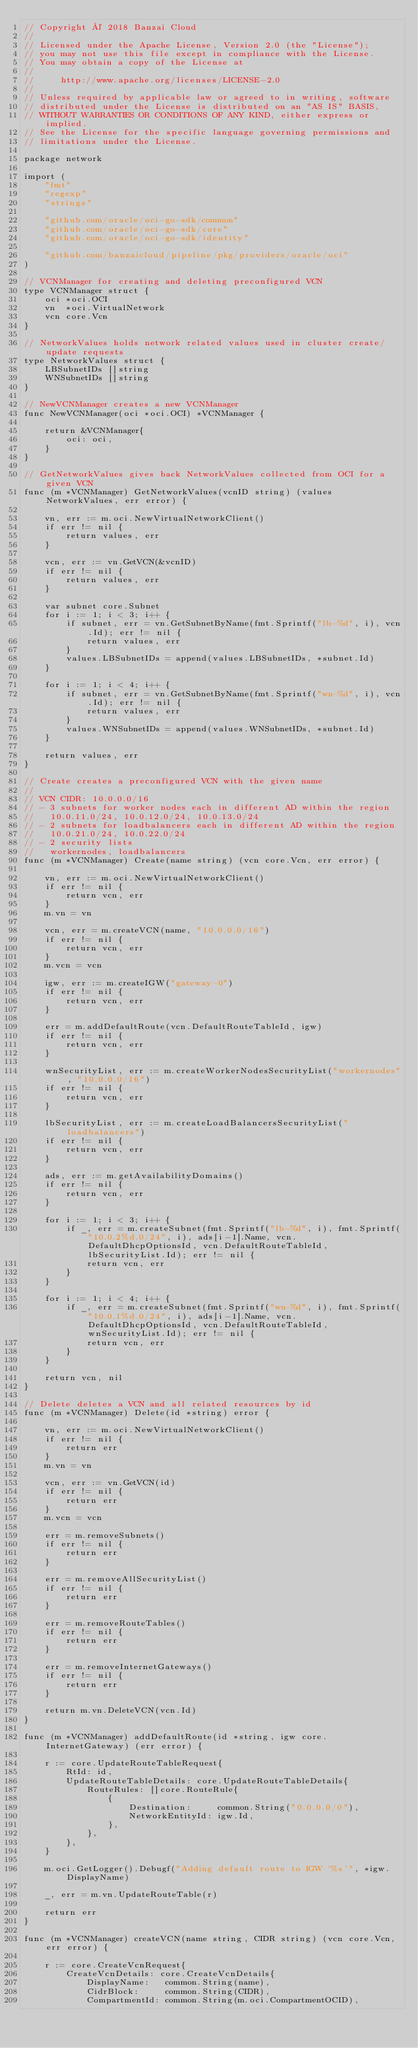<code> <loc_0><loc_0><loc_500><loc_500><_Go_>// Copyright © 2018 Banzai Cloud
//
// Licensed under the Apache License, Version 2.0 (the "License");
// you may not use this file except in compliance with the License.
// You may obtain a copy of the License at
//
//     http://www.apache.org/licenses/LICENSE-2.0
//
// Unless required by applicable law or agreed to in writing, software
// distributed under the License is distributed on an "AS IS" BASIS,
// WITHOUT WARRANTIES OR CONDITIONS OF ANY KIND, either express or implied.
// See the License for the specific language governing permissions and
// limitations under the License.

package network

import (
	"fmt"
	"regexp"
	"strings"

	"github.com/oracle/oci-go-sdk/common"
	"github.com/oracle/oci-go-sdk/core"
	"github.com/oracle/oci-go-sdk/identity"

	"github.com/banzaicloud/pipeline/pkg/providers/oracle/oci"
)

// VCNManager for creating and deleting preconfigured VCN
type VCNManager struct {
	oci *oci.OCI
	vn  *oci.VirtualNetwork
	vcn core.Vcn
}

// NetworkValues holds network related values used in cluster create/update requests
type NetworkValues struct {
	LBSubnetIDs []string
	WNSubnetIDs []string
}

// NewVCNManager creates a new VCNManager
func NewVCNManager(oci *oci.OCI) *VCNManager {

	return &VCNManager{
		oci: oci,
	}
}

// GetNetworkValues gives back NetworkValues collected from OCI for a given VCN
func (m *VCNManager) GetNetworkValues(vcnID string) (values NetworkValues, err error) {

	vn, err := m.oci.NewVirtualNetworkClient()
	if err != nil {
		return values, err
	}

	vcn, err := vn.GetVCN(&vcnID)
	if err != nil {
		return values, err
	}

	var subnet core.Subnet
	for i := 1; i < 3; i++ {
		if subnet, err = vn.GetSubnetByName(fmt.Sprintf("lb-%d", i), vcn.Id); err != nil {
			return values, err
		}
		values.LBSubnetIDs = append(values.LBSubnetIDs, *subnet.Id)
	}

	for i := 1; i < 4; i++ {
		if subnet, err = vn.GetSubnetByName(fmt.Sprintf("wn-%d", i), vcn.Id); err != nil {
			return values, err
		}
		values.WNSubnetIDs = append(values.WNSubnetIDs, *subnet.Id)
	}

	return values, err
}

// Create creates a preconfigured VCN with the given name
//
// VCN CIDR: 10.0.0.0/16
// - 3 subnets for worker nodes each in different AD within the region
//   10.0.11.0/24, 10.0.12.0/24, 10.0.13.0/24
// - 2 subnets for loadbalancers each in different AD within the region
//   10.0.21.0/24, 10.0.22.0/24
// - 2 security lists
//   workernodes, loadbalancers
func (m *VCNManager) Create(name string) (vcn core.Vcn, err error) {

	vn, err := m.oci.NewVirtualNetworkClient()
	if err != nil {
		return vcn, err
	}
	m.vn = vn

	vcn, err = m.createVCN(name, "10.0.0.0/16")
	if err != nil {
		return vcn, err
	}
	m.vcn = vcn

	igw, err := m.createIGW("gateway-0")
	if err != nil {
		return vcn, err
	}

	err = m.addDefaultRoute(vcn.DefaultRouteTableId, igw)
	if err != nil {
		return vcn, err
	}

	wnSecurityList, err := m.createWorkerNodesSecurityList("workernodes", "10.0.0.0/16")
	if err != nil {
		return vcn, err
	}

	lbSecurityList, err := m.createLoadBalancersSecurityList("loadbalancers")
	if err != nil {
		return vcn, err
	}

	ads, err := m.getAvailabilityDomains()
	if err != nil {
		return vcn, err
	}

	for i := 1; i < 3; i++ {
		if _, err = m.createSubnet(fmt.Sprintf("lb-%d", i), fmt.Sprintf("10.0.2%d.0/24", i), ads[i-1].Name, vcn.DefaultDhcpOptionsId, vcn.DefaultRouteTableId, lbSecurityList.Id); err != nil {
			return vcn, err
		}
	}

	for i := 1; i < 4; i++ {
		if _, err = m.createSubnet(fmt.Sprintf("wn-%d", i), fmt.Sprintf("10.0.1%d.0/24", i), ads[i-1].Name, vcn.DefaultDhcpOptionsId, vcn.DefaultRouteTableId, wnSecurityList.Id); err != nil {
			return vcn, err
		}
	}

	return vcn, nil
}

// Delete deletes a VCN and all related resources by id
func (m *VCNManager) Delete(id *string) error {

	vn, err := m.oci.NewVirtualNetworkClient()
	if err != nil {
		return err
	}
	m.vn = vn

	vcn, err := vn.GetVCN(id)
	if err != nil {
		return err
	}
	m.vcn = vcn

	err = m.removeSubnets()
	if err != nil {
		return err
	}

	err = m.removeAllSecurityList()
	if err != nil {
		return err
	}

	err = m.removeRouteTables()
	if err != nil {
		return err
	}

	err = m.removeInternetGateways()
	if err != nil {
		return err
	}

	return m.vn.DeleteVCN(vcn.Id)
}

func (m *VCNManager) addDefaultRoute(id *string, igw core.InternetGateway) (err error) {

	r := core.UpdateRouteTableRequest{
		RtId: id,
		UpdateRouteTableDetails: core.UpdateRouteTableDetails{
			RouteRules: []core.RouteRule{
				{
					Destination:     common.String("0.0.0.0/0"),
					NetworkEntityId: igw.Id,
				},
			},
		},
	}

	m.oci.GetLogger().Debugf("Adding default route to IGW '%s'", *igw.DisplayName)

	_, err = m.vn.UpdateRouteTable(r)

	return err
}

func (m *VCNManager) createVCN(name string, CIDR string) (vcn core.Vcn, err error) {

	r := core.CreateVcnRequest{
		CreateVcnDetails: core.CreateVcnDetails{
			DisplayName:   common.String(name),
			CidrBlock:     common.String(CIDR),
			CompartmentId: common.String(m.oci.CompartmentOCID),</code> 